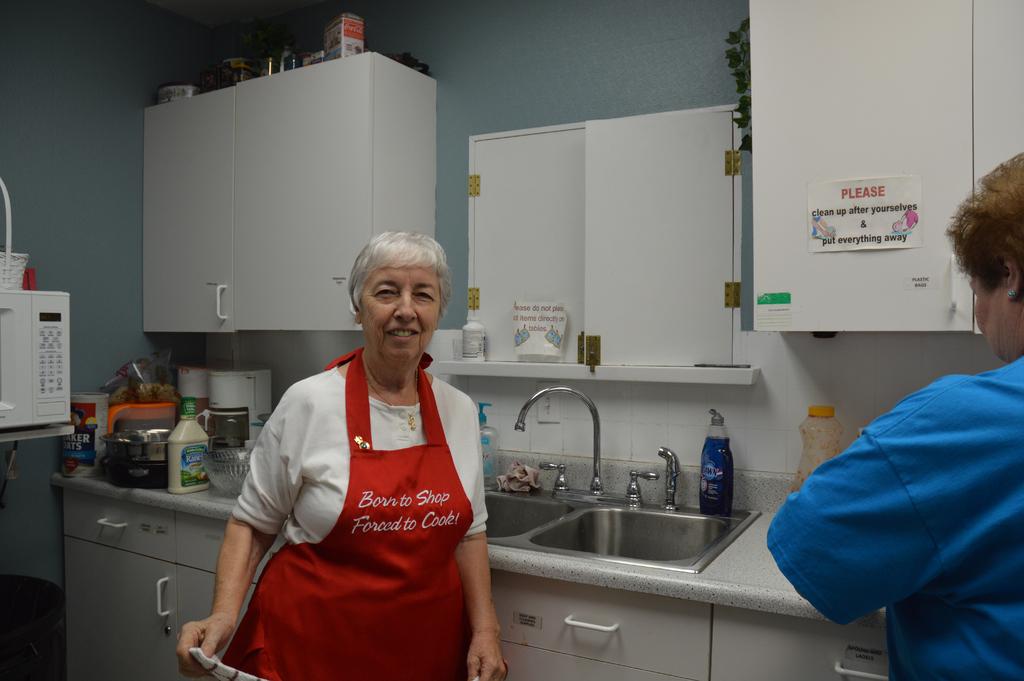What does the sign on the cupboard want the employees to do?
Offer a very short reply. Please clean up after yourselves & put everything away. Does does the woman's apron say she was born to do?
Offer a terse response. Shop. 